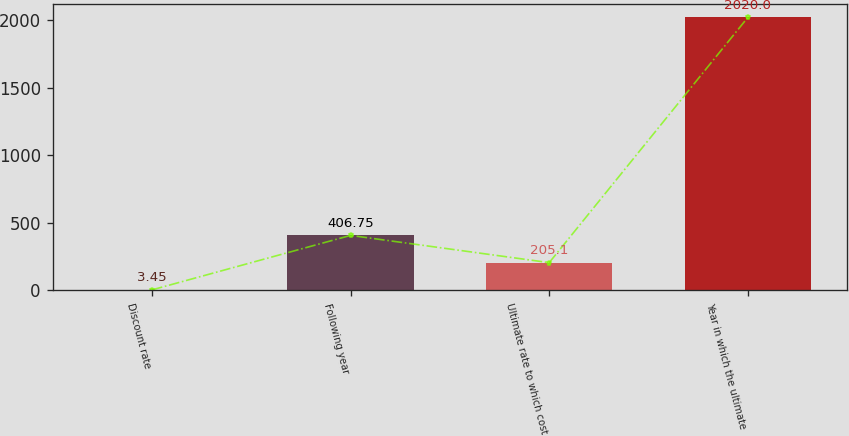Convert chart. <chart><loc_0><loc_0><loc_500><loc_500><bar_chart><fcel>Discount rate<fcel>Following year<fcel>Ultimate rate to which cost<fcel>Year in which the ultimate<nl><fcel>3.45<fcel>406.75<fcel>205.1<fcel>2020<nl></chart> 